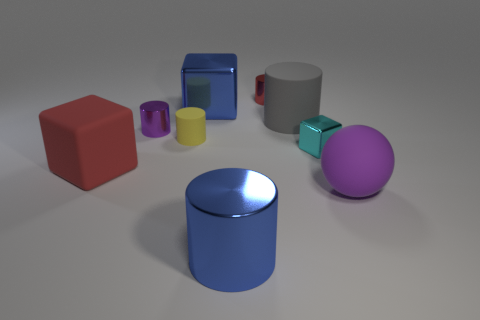What material is the other blue object that is the same shape as the small rubber object?
Provide a short and direct response. Metal. The large object that is to the right of the gray matte thing has what shape?
Your response must be concise. Sphere. Are there any blue cylinders made of the same material as the yellow cylinder?
Keep it short and to the point. No. Is the size of the gray cylinder the same as the yellow matte cylinder?
Provide a succinct answer. No. How many cylinders are tiny brown objects or tiny yellow things?
Provide a short and direct response. 1. What number of red metal objects are the same shape as the tiny yellow rubber thing?
Your answer should be compact. 1. Is the number of big blue things that are in front of the purple matte sphere greater than the number of small cyan objects that are behind the red cylinder?
Make the answer very short. Yes. There is a metallic block that is on the left side of the small red object; does it have the same color as the large metallic cylinder?
Provide a succinct answer. Yes. What is the size of the purple sphere?
Your answer should be compact. Large. What is the material of the red cylinder that is the same size as the cyan thing?
Offer a very short reply. Metal. 